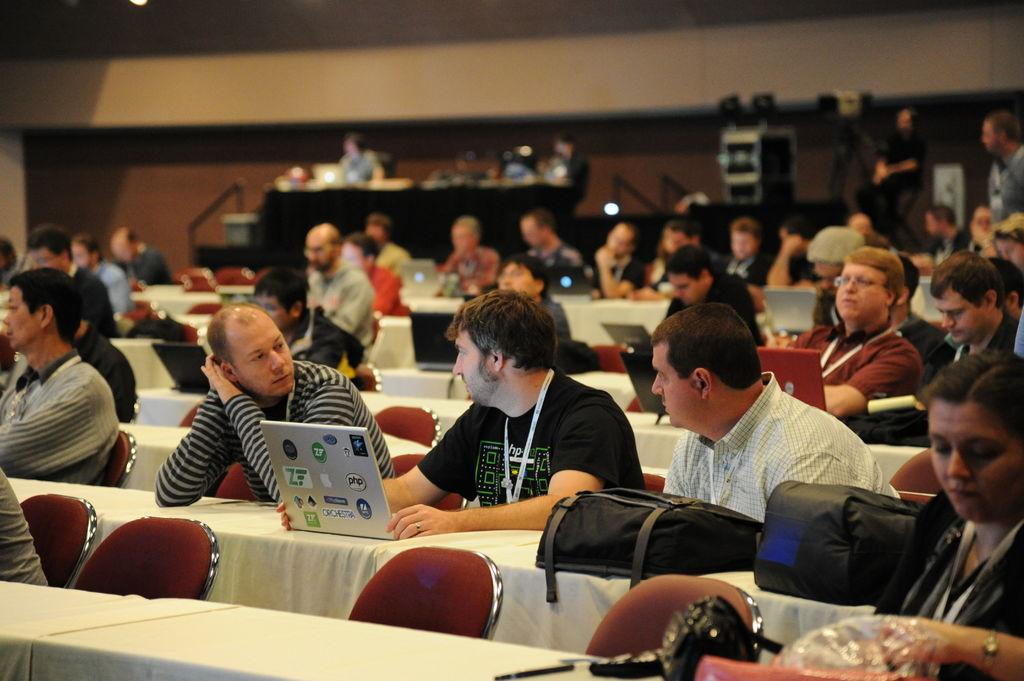What are the people in the image doing? The people in the image are sitting and working on laptops. Can you describe the setting in which the people are working? There is a wall and a stage in the background of the image. How many people are in the group? The number of people in the group is not specified, but there is a group of people present in the image. How many horses can be seen on the stage in the image? There are no horses present in the image; the stage is in the background, and the people are working on laptops. 